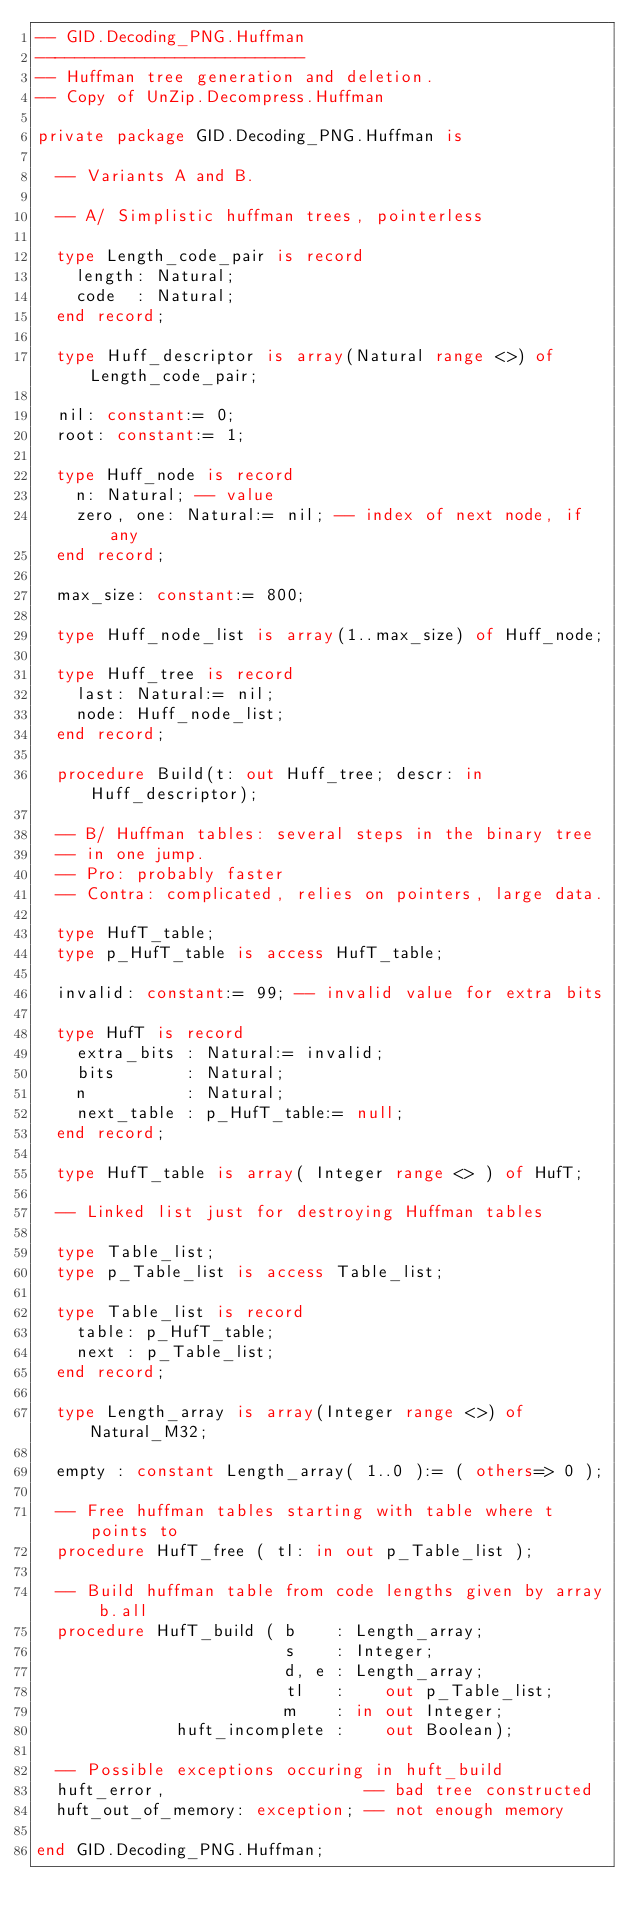Convert code to text. <code><loc_0><loc_0><loc_500><loc_500><_Ada_>-- GID.Decoding_PNG.Huffman
---------------------------
-- Huffman tree generation and deletion.
-- Copy of UnZip.Decompress.Huffman

private package GID.Decoding_PNG.Huffman is

  -- Variants A and B.

  -- A/ Simplistic huffman trees, pointerless

  type Length_code_pair is record
    length: Natural;
    code  : Natural;
  end record;

  type Huff_descriptor is array(Natural range <>) of Length_code_pair;

  nil: constant:= 0;
  root: constant:= 1;

  type Huff_node is record
    n: Natural; -- value
    zero, one: Natural:= nil; -- index of next node, if any
  end record;

  max_size: constant:= 800;

  type Huff_node_list is array(1..max_size) of Huff_node;

  type Huff_tree is record
    last: Natural:= nil;
    node: Huff_node_list;
  end record;

  procedure Build(t: out Huff_tree; descr: in Huff_descriptor);

  -- B/ Huffman tables: several steps in the binary tree
  -- in one jump.
  -- Pro: probably faster
  -- Contra: complicated, relies on pointers, large data.

  type HufT_table;
  type p_HufT_table is access HufT_table;

  invalid: constant:= 99; -- invalid value for extra bits

  type HufT is record
    extra_bits : Natural:= invalid;
    bits       : Natural;
    n          : Natural;
    next_table : p_HufT_table:= null;
  end record;

  type HufT_table is array( Integer range <> ) of HufT;

  -- Linked list just for destroying Huffman tables

  type Table_list;
  type p_Table_list is access Table_list;

  type Table_list is record
    table: p_HufT_table;
    next : p_Table_list;
  end record;

  type Length_array is array(Integer range <>) of Natural_M32;

  empty : constant Length_array( 1..0 ):= ( others=> 0 );

  -- Free huffman tables starting with table where t points to
  procedure HufT_free ( tl: in out p_Table_list );

  -- Build huffman table from code lengths given by array b.all
  procedure HufT_build ( b    : Length_array;
                         s    : Integer;
                         d, e : Length_array;
                         tl   :    out p_Table_list;
                         m    : in out Integer;
              huft_incomplete :    out Boolean);

  -- Possible exceptions occuring in huft_build
  huft_error,                    -- bad tree constructed
  huft_out_of_memory: exception; -- not enough memory

end GID.Decoding_PNG.Huffman;
</code> 